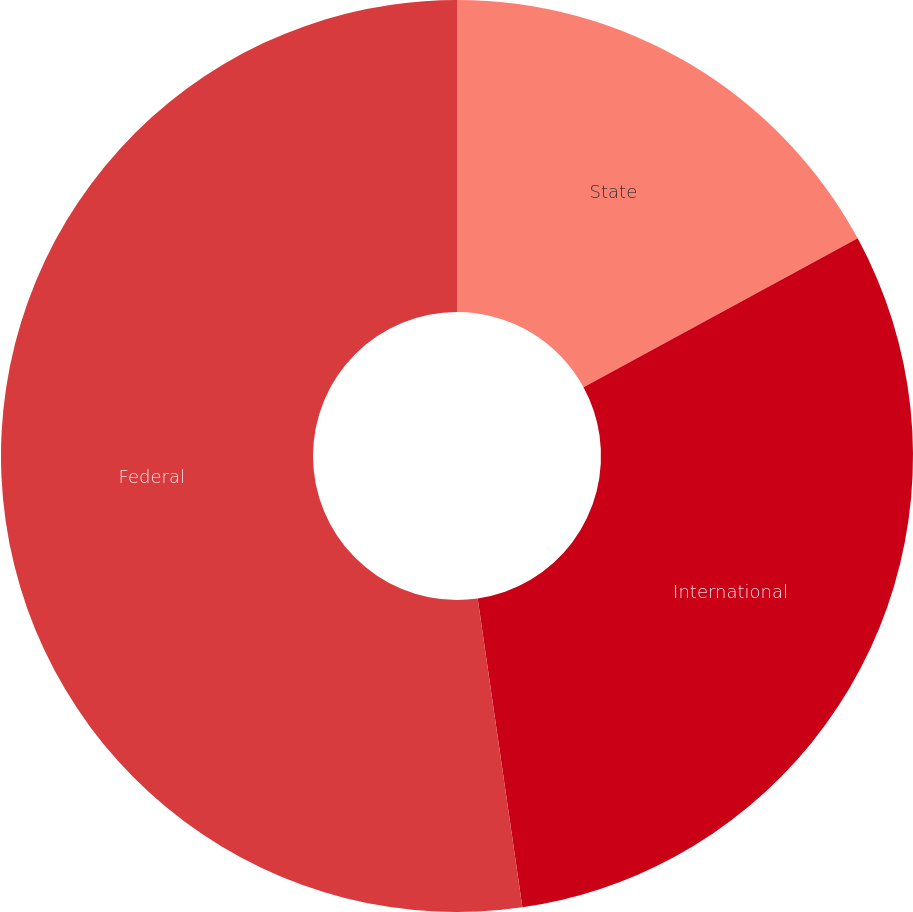<chart> <loc_0><loc_0><loc_500><loc_500><pie_chart><fcel>State<fcel>International<fcel>Federal<nl><fcel>17.08%<fcel>30.63%<fcel>52.29%<nl></chart> 